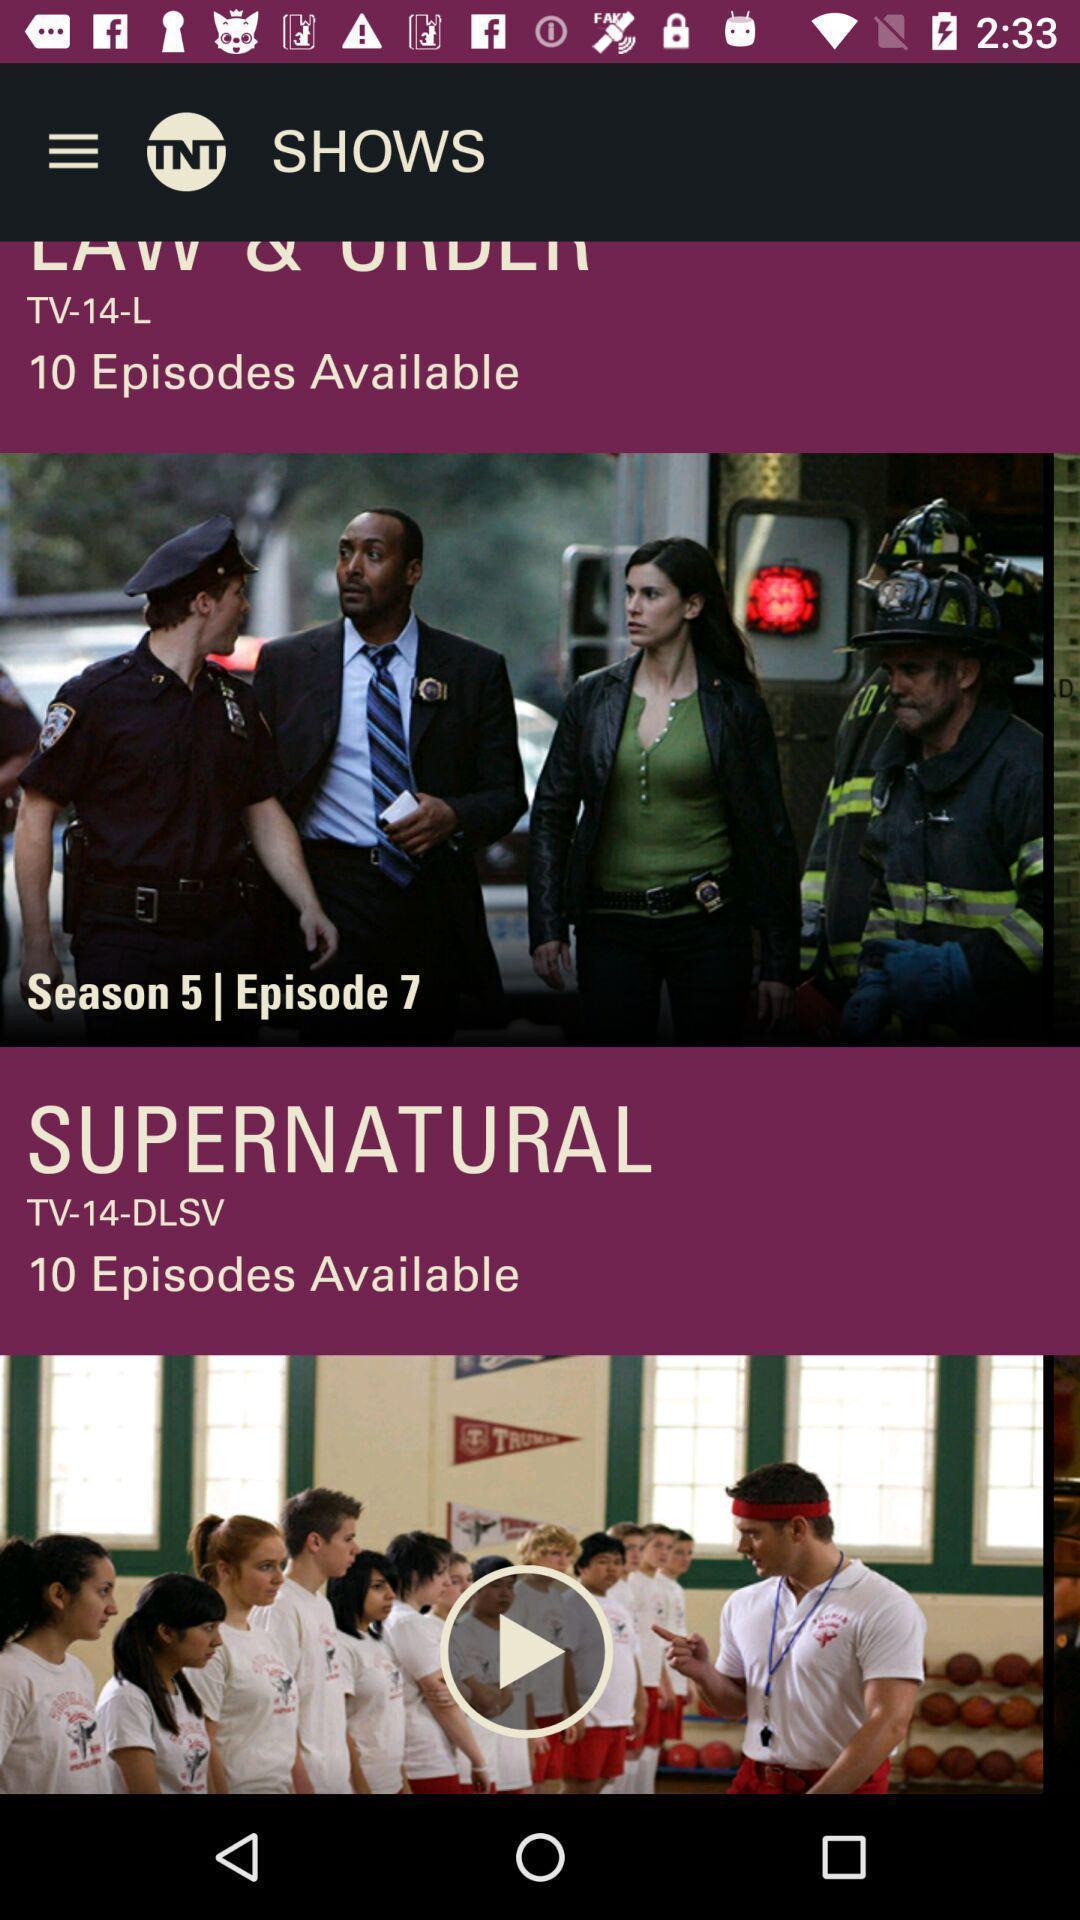Provide a detailed account of this screenshot. Screen showing episodes in an entertainment application. 